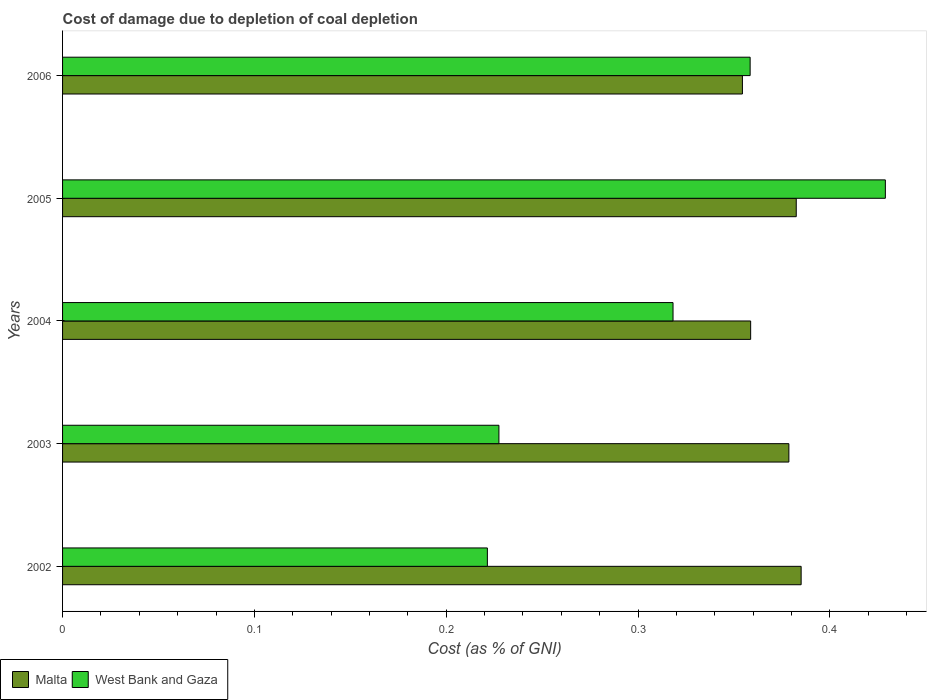Are the number of bars per tick equal to the number of legend labels?
Provide a succinct answer. Yes. In how many cases, is the number of bars for a given year not equal to the number of legend labels?
Make the answer very short. 0. What is the cost of damage caused due to coal depletion in West Bank and Gaza in 2006?
Your answer should be compact. 0.36. Across all years, what is the maximum cost of damage caused due to coal depletion in Malta?
Provide a succinct answer. 0.39. Across all years, what is the minimum cost of damage caused due to coal depletion in Malta?
Give a very brief answer. 0.35. In which year was the cost of damage caused due to coal depletion in Malta maximum?
Make the answer very short. 2002. In which year was the cost of damage caused due to coal depletion in West Bank and Gaza minimum?
Your answer should be very brief. 2002. What is the total cost of damage caused due to coal depletion in West Bank and Gaza in the graph?
Your answer should be compact. 1.55. What is the difference between the cost of damage caused due to coal depletion in West Bank and Gaza in 2005 and that in 2006?
Offer a very short reply. 0.07. What is the difference between the cost of damage caused due to coal depletion in Malta in 2005 and the cost of damage caused due to coal depletion in West Bank and Gaza in 2003?
Provide a short and direct response. 0.15. What is the average cost of damage caused due to coal depletion in West Bank and Gaza per year?
Offer a very short reply. 0.31. In the year 2004, what is the difference between the cost of damage caused due to coal depletion in Malta and cost of damage caused due to coal depletion in West Bank and Gaza?
Your answer should be compact. 0.04. What is the ratio of the cost of damage caused due to coal depletion in West Bank and Gaza in 2002 to that in 2003?
Offer a terse response. 0.97. What is the difference between the highest and the second highest cost of damage caused due to coal depletion in West Bank and Gaza?
Provide a succinct answer. 0.07. What is the difference between the highest and the lowest cost of damage caused due to coal depletion in Malta?
Make the answer very short. 0.03. Is the sum of the cost of damage caused due to coal depletion in West Bank and Gaza in 2004 and 2005 greater than the maximum cost of damage caused due to coal depletion in Malta across all years?
Make the answer very short. Yes. What does the 2nd bar from the top in 2002 represents?
Provide a succinct answer. Malta. What does the 2nd bar from the bottom in 2006 represents?
Provide a succinct answer. West Bank and Gaza. How many years are there in the graph?
Offer a very short reply. 5. What is the title of the graph?
Give a very brief answer. Cost of damage due to depletion of coal depletion. What is the label or title of the X-axis?
Make the answer very short. Cost (as % of GNI). What is the label or title of the Y-axis?
Offer a very short reply. Years. What is the Cost (as % of GNI) of Malta in 2002?
Provide a short and direct response. 0.39. What is the Cost (as % of GNI) in West Bank and Gaza in 2002?
Your answer should be very brief. 0.22. What is the Cost (as % of GNI) of Malta in 2003?
Your answer should be compact. 0.38. What is the Cost (as % of GNI) of West Bank and Gaza in 2003?
Offer a terse response. 0.23. What is the Cost (as % of GNI) of Malta in 2004?
Your answer should be very brief. 0.36. What is the Cost (as % of GNI) in West Bank and Gaza in 2004?
Provide a succinct answer. 0.32. What is the Cost (as % of GNI) of Malta in 2005?
Offer a very short reply. 0.38. What is the Cost (as % of GNI) in West Bank and Gaza in 2005?
Offer a terse response. 0.43. What is the Cost (as % of GNI) of Malta in 2006?
Ensure brevity in your answer.  0.35. What is the Cost (as % of GNI) in West Bank and Gaza in 2006?
Give a very brief answer. 0.36. Across all years, what is the maximum Cost (as % of GNI) of Malta?
Ensure brevity in your answer.  0.39. Across all years, what is the maximum Cost (as % of GNI) in West Bank and Gaza?
Your answer should be very brief. 0.43. Across all years, what is the minimum Cost (as % of GNI) of Malta?
Offer a very short reply. 0.35. Across all years, what is the minimum Cost (as % of GNI) of West Bank and Gaza?
Give a very brief answer. 0.22. What is the total Cost (as % of GNI) of Malta in the graph?
Make the answer very short. 1.86. What is the total Cost (as % of GNI) in West Bank and Gaza in the graph?
Give a very brief answer. 1.55. What is the difference between the Cost (as % of GNI) of Malta in 2002 and that in 2003?
Offer a very short reply. 0.01. What is the difference between the Cost (as % of GNI) in West Bank and Gaza in 2002 and that in 2003?
Offer a terse response. -0.01. What is the difference between the Cost (as % of GNI) in Malta in 2002 and that in 2004?
Provide a short and direct response. 0.03. What is the difference between the Cost (as % of GNI) in West Bank and Gaza in 2002 and that in 2004?
Your answer should be compact. -0.1. What is the difference between the Cost (as % of GNI) of Malta in 2002 and that in 2005?
Offer a very short reply. 0. What is the difference between the Cost (as % of GNI) in West Bank and Gaza in 2002 and that in 2005?
Your response must be concise. -0.21. What is the difference between the Cost (as % of GNI) of Malta in 2002 and that in 2006?
Keep it short and to the point. 0.03. What is the difference between the Cost (as % of GNI) in West Bank and Gaza in 2002 and that in 2006?
Your answer should be very brief. -0.14. What is the difference between the Cost (as % of GNI) in Malta in 2003 and that in 2004?
Provide a succinct answer. 0.02. What is the difference between the Cost (as % of GNI) of West Bank and Gaza in 2003 and that in 2004?
Give a very brief answer. -0.09. What is the difference between the Cost (as % of GNI) in Malta in 2003 and that in 2005?
Your response must be concise. -0. What is the difference between the Cost (as % of GNI) of West Bank and Gaza in 2003 and that in 2005?
Make the answer very short. -0.2. What is the difference between the Cost (as % of GNI) of Malta in 2003 and that in 2006?
Offer a terse response. 0.02. What is the difference between the Cost (as % of GNI) of West Bank and Gaza in 2003 and that in 2006?
Your response must be concise. -0.13. What is the difference between the Cost (as % of GNI) in Malta in 2004 and that in 2005?
Make the answer very short. -0.02. What is the difference between the Cost (as % of GNI) in West Bank and Gaza in 2004 and that in 2005?
Your answer should be compact. -0.11. What is the difference between the Cost (as % of GNI) in Malta in 2004 and that in 2006?
Offer a very short reply. 0. What is the difference between the Cost (as % of GNI) in West Bank and Gaza in 2004 and that in 2006?
Provide a succinct answer. -0.04. What is the difference between the Cost (as % of GNI) of Malta in 2005 and that in 2006?
Keep it short and to the point. 0.03. What is the difference between the Cost (as % of GNI) of West Bank and Gaza in 2005 and that in 2006?
Your answer should be very brief. 0.07. What is the difference between the Cost (as % of GNI) in Malta in 2002 and the Cost (as % of GNI) in West Bank and Gaza in 2003?
Your answer should be very brief. 0.16. What is the difference between the Cost (as % of GNI) in Malta in 2002 and the Cost (as % of GNI) in West Bank and Gaza in 2004?
Provide a succinct answer. 0.07. What is the difference between the Cost (as % of GNI) in Malta in 2002 and the Cost (as % of GNI) in West Bank and Gaza in 2005?
Your answer should be compact. -0.04. What is the difference between the Cost (as % of GNI) of Malta in 2002 and the Cost (as % of GNI) of West Bank and Gaza in 2006?
Provide a succinct answer. 0.03. What is the difference between the Cost (as % of GNI) in Malta in 2003 and the Cost (as % of GNI) in West Bank and Gaza in 2004?
Make the answer very short. 0.06. What is the difference between the Cost (as % of GNI) in Malta in 2003 and the Cost (as % of GNI) in West Bank and Gaza in 2005?
Offer a terse response. -0.05. What is the difference between the Cost (as % of GNI) in Malta in 2003 and the Cost (as % of GNI) in West Bank and Gaza in 2006?
Your response must be concise. 0.02. What is the difference between the Cost (as % of GNI) of Malta in 2004 and the Cost (as % of GNI) of West Bank and Gaza in 2005?
Offer a terse response. -0.07. What is the difference between the Cost (as % of GNI) in Malta in 2004 and the Cost (as % of GNI) in West Bank and Gaza in 2006?
Make the answer very short. 0. What is the difference between the Cost (as % of GNI) in Malta in 2005 and the Cost (as % of GNI) in West Bank and Gaza in 2006?
Your response must be concise. 0.02. What is the average Cost (as % of GNI) of Malta per year?
Your answer should be very brief. 0.37. What is the average Cost (as % of GNI) in West Bank and Gaza per year?
Offer a very short reply. 0.31. In the year 2002, what is the difference between the Cost (as % of GNI) in Malta and Cost (as % of GNI) in West Bank and Gaza?
Your answer should be very brief. 0.16. In the year 2003, what is the difference between the Cost (as % of GNI) of Malta and Cost (as % of GNI) of West Bank and Gaza?
Ensure brevity in your answer.  0.15. In the year 2004, what is the difference between the Cost (as % of GNI) in Malta and Cost (as % of GNI) in West Bank and Gaza?
Provide a succinct answer. 0.04. In the year 2005, what is the difference between the Cost (as % of GNI) in Malta and Cost (as % of GNI) in West Bank and Gaza?
Provide a short and direct response. -0.05. In the year 2006, what is the difference between the Cost (as % of GNI) in Malta and Cost (as % of GNI) in West Bank and Gaza?
Your answer should be very brief. -0. What is the ratio of the Cost (as % of GNI) of Malta in 2002 to that in 2003?
Keep it short and to the point. 1.02. What is the ratio of the Cost (as % of GNI) in West Bank and Gaza in 2002 to that in 2003?
Provide a short and direct response. 0.97. What is the ratio of the Cost (as % of GNI) in Malta in 2002 to that in 2004?
Give a very brief answer. 1.07. What is the ratio of the Cost (as % of GNI) of West Bank and Gaza in 2002 to that in 2004?
Your answer should be compact. 0.7. What is the ratio of the Cost (as % of GNI) in West Bank and Gaza in 2002 to that in 2005?
Provide a short and direct response. 0.52. What is the ratio of the Cost (as % of GNI) in Malta in 2002 to that in 2006?
Offer a very short reply. 1.09. What is the ratio of the Cost (as % of GNI) in West Bank and Gaza in 2002 to that in 2006?
Your answer should be very brief. 0.62. What is the ratio of the Cost (as % of GNI) of Malta in 2003 to that in 2004?
Your answer should be compact. 1.06. What is the ratio of the Cost (as % of GNI) of West Bank and Gaza in 2003 to that in 2004?
Provide a short and direct response. 0.71. What is the ratio of the Cost (as % of GNI) in Malta in 2003 to that in 2005?
Provide a succinct answer. 0.99. What is the ratio of the Cost (as % of GNI) of West Bank and Gaza in 2003 to that in 2005?
Offer a very short reply. 0.53. What is the ratio of the Cost (as % of GNI) of Malta in 2003 to that in 2006?
Keep it short and to the point. 1.07. What is the ratio of the Cost (as % of GNI) of West Bank and Gaza in 2003 to that in 2006?
Keep it short and to the point. 0.63. What is the ratio of the Cost (as % of GNI) of Malta in 2004 to that in 2005?
Keep it short and to the point. 0.94. What is the ratio of the Cost (as % of GNI) in West Bank and Gaza in 2004 to that in 2005?
Your response must be concise. 0.74. What is the ratio of the Cost (as % of GNI) in Malta in 2004 to that in 2006?
Provide a succinct answer. 1.01. What is the ratio of the Cost (as % of GNI) in West Bank and Gaza in 2004 to that in 2006?
Your response must be concise. 0.89. What is the ratio of the Cost (as % of GNI) of Malta in 2005 to that in 2006?
Keep it short and to the point. 1.08. What is the ratio of the Cost (as % of GNI) in West Bank and Gaza in 2005 to that in 2006?
Make the answer very short. 1.2. What is the difference between the highest and the second highest Cost (as % of GNI) of Malta?
Make the answer very short. 0. What is the difference between the highest and the second highest Cost (as % of GNI) in West Bank and Gaza?
Your response must be concise. 0.07. What is the difference between the highest and the lowest Cost (as % of GNI) in Malta?
Offer a very short reply. 0.03. What is the difference between the highest and the lowest Cost (as % of GNI) in West Bank and Gaza?
Ensure brevity in your answer.  0.21. 